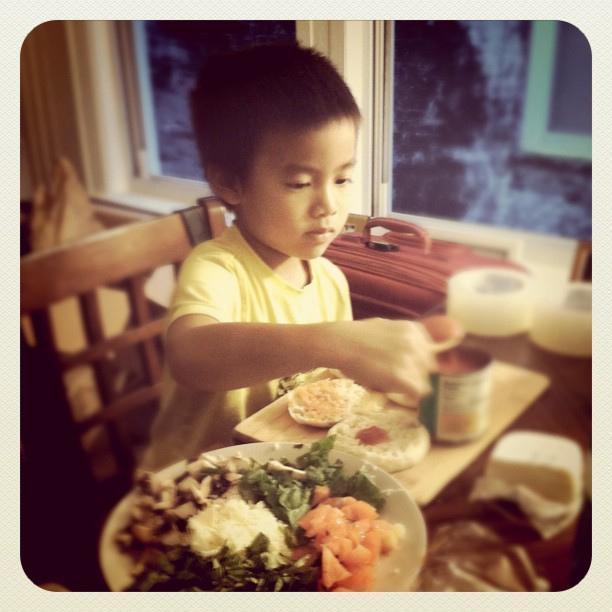How many different kinds of food are on the plate to the boy's right?
Give a very brief answer. 5. How many hands are holding the sandwiches?
Give a very brief answer. 1. How many dining tables are there?
Give a very brief answer. 2. 